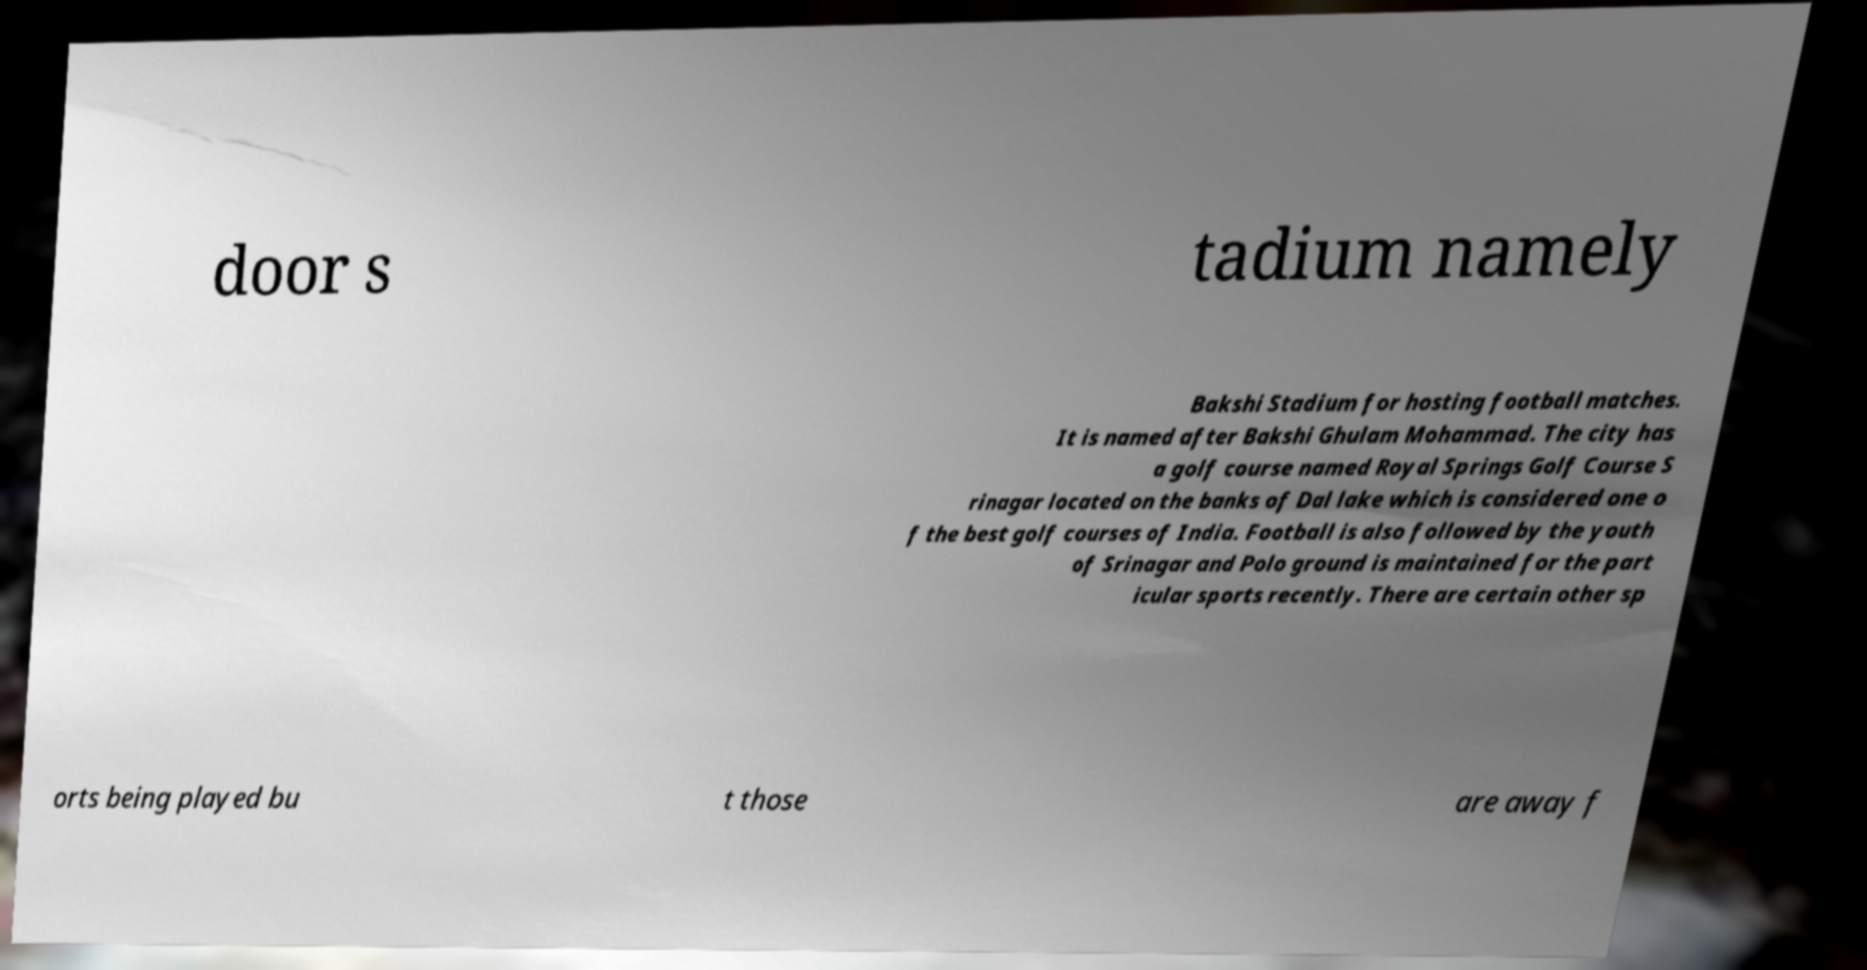Could you assist in decoding the text presented in this image and type it out clearly? door s tadium namely Bakshi Stadium for hosting football matches. It is named after Bakshi Ghulam Mohammad. The city has a golf course named Royal Springs Golf Course S rinagar located on the banks of Dal lake which is considered one o f the best golf courses of India. Football is also followed by the youth of Srinagar and Polo ground is maintained for the part icular sports recently. There are certain other sp orts being played bu t those are away f 